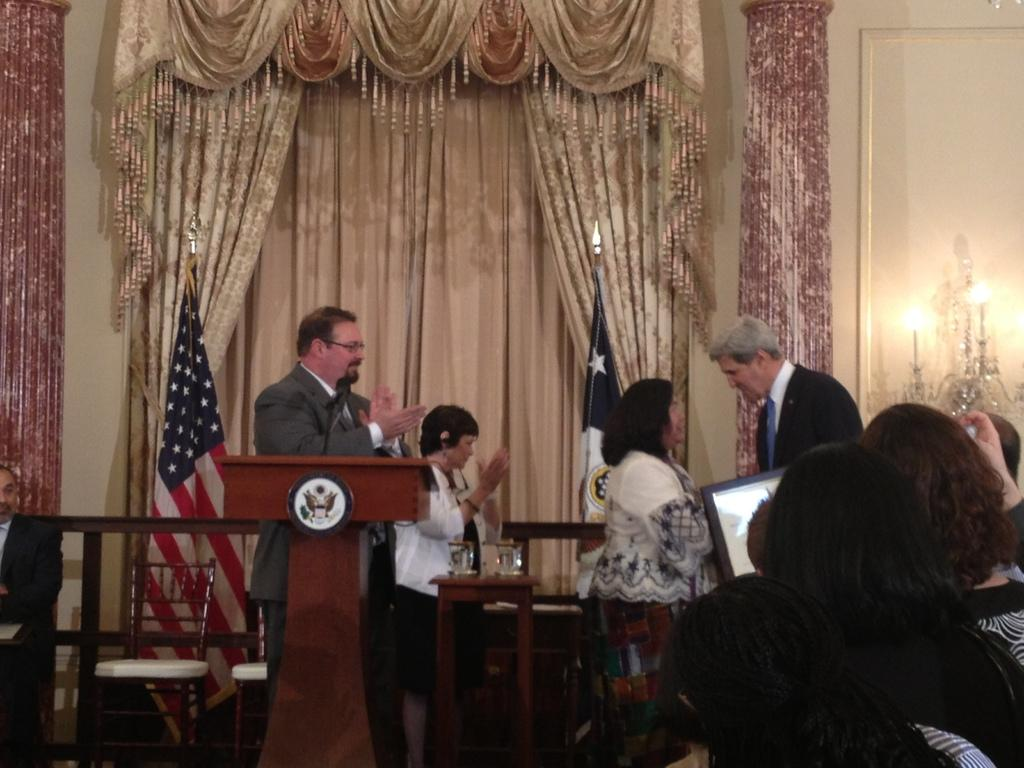How many people can be seen in the image? There are persons standing in the image. What can be seen in the background of the image? There is a wall, a frame, lights, a flag, and a curtain in the background of the image. What furniture is present in the image? There are chairs, a table, and a podium in the image. What object is on the table? There is a glass on the table. What device is present for amplifying sound? There is a microphone in the image. What is the reason for the protest happening in the image? There is no protest happening in the image, so there is no reason to discuss. 